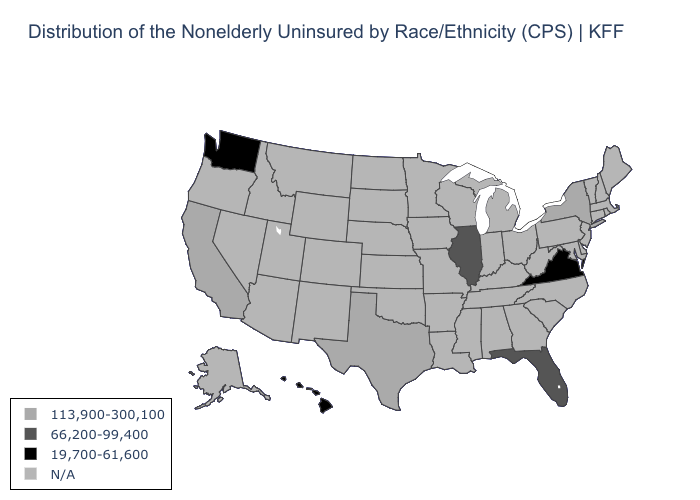Name the states that have a value in the range N/A?
Write a very short answer. Alabama, Alaska, Arizona, Arkansas, Colorado, Connecticut, Delaware, Georgia, Idaho, Indiana, Iowa, Kansas, Kentucky, Louisiana, Maine, Maryland, Massachusetts, Michigan, Minnesota, Mississippi, Missouri, Montana, Nebraska, Nevada, New Hampshire, New Jersey, New Mexico, North Carolina, North Dakota, Ohio, Oklahoma, Oregon, Pennsylvania, Rhode Island, South Carolina, South Dakota, Tennessee, Utah, Vermont, West Virginia, Wisconsin, Wyoming. What is the value of Tennessee?
Short answer required. N/A. Name the states that have a value in the range N/A?
Keep it brief. Alabama, Alaska, Arizona, Arkansas, Colorado, Connecticut, Delaware, Georgia, Idaho, Indiana, Iowa, Kansas, Kentucky, Louisiana, Maine, Maryland, Massachusetts, Michigan, Minnesota, Mississippi, Missouri, Montana, Nebraska, Nevada, New Hampshire, New Jersey, New Mexico, North Carolina, North Dakota, Ohio, Oklahoma, Oregon, Pennsylvania, Rhode Island, South Carolina, South Dakota, Tennessee, Utah, Vermont, West Virginia, Wisconsin, Wyoming. Does the map have missing data?
Short answer required. Yes. What is the value of Michigan?
Answer briefly. N/A. Name the states that have a value in the range 113,900-300,100?
Give a very brief answer. California, New York, Texas. What is the value of Vermont?
Give a very brief answer. N/A. Which states have the lowest value in the South?
Quick response, please. Virginia. Name the states that have a value in the range 113,900-300,100?
Concise answer only. California, New York, Texas. What is the highest value in the MidWest ?
Concise answer only. 66,200-99,400. What is the highest value in the South ?
Write a very short answer. 113,900-300,100. Does Hawaii have the lowest value in the USA?
Answer briefly. Yes. What is the value of Maryland?
Give a very brief answer. N/A. Does the first symbol in the legend represent the smallest category?
Keep it brief. No. 